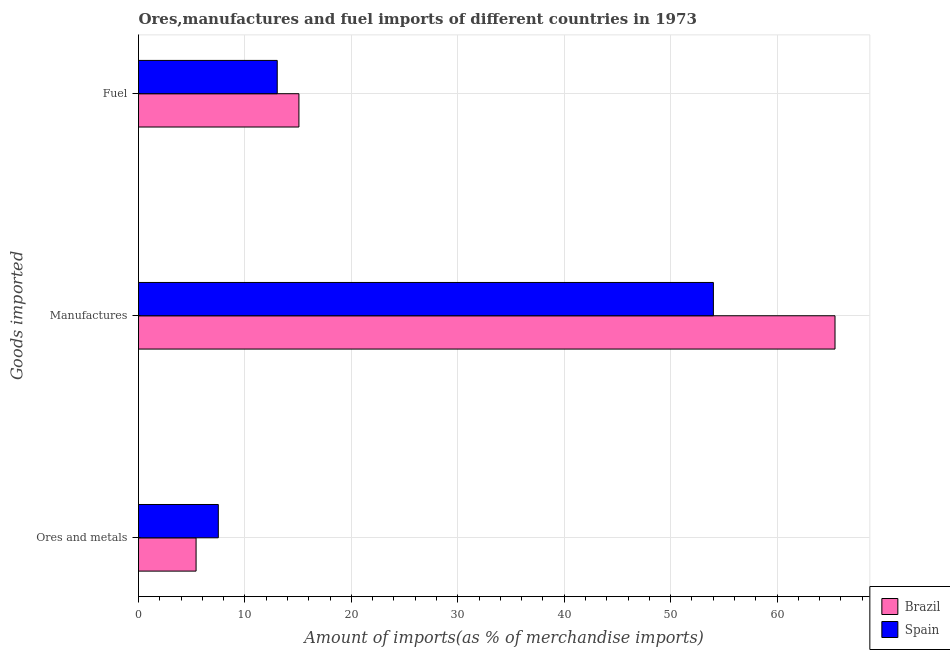Are the number of bars per tick equal to the number of legend labels?
Keep it short and to the point. Yes. Are the number of bars on each tick of the Y-axis equal?
Your answer should be compact. Yes. How many bars are there on the 2nd tick from the top?
Your answer should be compact. 2. What is the label of the 1st group of bars from the top?
Ensure brevity in your answer.  Fuel. What is the percentage of manufactures imports in Spain?
Offer a very short reply. 54.02. Across all countries, what is the maximum percentage of manufactures imports?
Keep it short and to the point. 65.45. Across all countries, what is the minimum percentage of fuel imports?
Your response must be concise. 13.04. In which country was the percentage of fuel imports minimum?
Your response must be concise. Spain. What is the total percentage of fuel imports in the graph?
Your answer should be compact. 28.11. What is the difference between the percentage of manufactures imports in Brazil and that in Spain?
Your answer should be very brief. 11.43. What is the difference between the percentage of fuel imports in Brazil and the percentage of manufactures imports in Spain?
Keep it short and to the point. -38.95. What is the average percentage of manufactures imports per country?
Your answer should be very brief. 59.73. What is the difference between the percentage of manufactures imports and percentage of fuel imports in Spain?
Make the answer very short. 40.98. In how many countries, is the percentage of ores and metals imports greater than 46 %?
Your response must be concise. 0. What is the ratio of the percentage of manufactures imports in Spain to that in Brazil?
Make the answer very short. 0.83. Is the percentage of ores and metals imports in Brazil less than that in Spain?
Your answer should be compact. Yes. Is the difference between the percentage of manufactures imports in Spain and Brazil greater than the difference between the percentage of fuel imports in Spain and Brazil?
Your response must be concise. No. What is the difference between the highest and the second highest percentage of manufactures imports?
Your response must be concise. 11.43. What is the difference between the highest and the lowest percentage of ores and metals imports?
Ensure brevity in your answer.  2.09. In how many countries, is the percentage of fuel imports greater than the average percentage of fuel imports taken over all countries?
Keep it short and to the point. 1. What does the 2nd bar from the bottom in Fuel represents?
Offer a very short reply. Spain. How many bars are there?
Ensure brevity in your answer.  6. How many countries are there in the graph?
Your answer should be very brief. 2. What is the difference between two consecutive major ticks on the X-axis?
Give a very brief answer. 10. Does the graph contain any zero values?
Offer a very short reply. No. Does the graph contain grids?
Provide a succinct answer. Yes. How are the legend labels stacked?
Offer a very short reply. Vertical. What is the title of the graph?
Provide a short and direct response. Ores,manufactures and fuel imports of different countries in 1973. What is the label or title of the X-axis?
Keep it short and to the point. Amount of imports(as % of merchandise imports). What is the label or title of the Y-axis?
Offer a very short reply. Goods imported. What is the Amount of imports(as % of merchandise imports) of Brazil in Ores and metals?
Your answer should be very brief. 5.41. What is the Amount of imports(as % of merchandise imports) in Spain in Ores and metals?
Your answer should be very brief. 7.5. What is the Amount of imports(as % of merchandise imports) of Brazil in Manufactures?
Provide a succinct answer. 65.45. What is the Amount of imports(as % of merchandise imports) in Spain in Manufactures?
Make the answer very short. 54.02. What is the Amount of imports(as % of merchandise imports) in Brazil in Fuel?
Provide a succinct answer. 15.07. What is the Amount of imports(as % of merchandise imports) of Spain in Fuel?
Your response must be concise. 13.04. Across all Goods imported, what is the maximum Amount of imports(as % of merchandise imports) in Brazil?
Your response must be concise. 65.45. Across all Goods imported, what is the maximum Amount of imports(as % of merchandise imports) in Spain?
Provide a succinct answer. 54.02. Across all Goods imported, what is the minimum Amount of imports(as % of merchandise imports) of Brazil?
Provide a succinct answer. 5.41. Across all Goods imported, what is the minimum Amount of imports(as % of merchandise imports) of Spain?
Ensure brevity in your answer.  7.5. What is the total Amount of imports(as % of merchandise imports) of Brazil in the graph?
Make the answer very short. 85.93. What is the total Amount of imports(as % of merchandise imports) of Spain in the graph?
Your response must be concise. 74.55. What is the difference between the Amount of imports(as % of merchandise imports) in Brazil in Ores and metals and that in Manufactures?
Give a very brief answer. -60.04. What is the difference between the Amount of imports(as % of merchandise imports) in Spain in Ores and metals and that in Manufactures?
Your response must be concise. -46.52. What is the difference between the Amount of imports(as % of merchandise imports) in Brazil in Ores and metals and that in Fuel?
Ensure brevity in your answer.  -9.66. What is the difference between the Amount of imports(as % of merchandise imports) of Spain in Ores and metals and that in Fuel?
Make the answer very short. -5.54. What is the difference between the Amount of imports(as % of merchandise imports) in Brazil in Manufactures and that in Fuel?
Your answer should be very brief. 50.37. What is the difference between the Amount of imports(as % of merchandise imports) of Spain in Manufactures and that in Fuel?
Your response must be concise. 40.98. What is the difference between the Amount of imports(as % of merchandise imports) of Brazil in Ores and metals and the Amount of imports(as % of merchandise imports) of Spain in Manufactures?
Keep it short and to the point. -48.61. What is the difference between the Amount of imports(as % of merchandise imports) in Brazil in Ores and metals and the Amount of imports(as % of merchandise imports) in Spain in Fuel?
Give a very brief answer. -7.63. What is the difference between the Amount of imports(as % of merchandise imports) in Brazil in Manufactures and the Amount of imports(as % of merchandise imports) in Spain in Fuel?
Provide a short and direct response. 52.41. What is the average Amount of imports(as % of merchandise imports) in Brazil per Goods imported?
Your answer should be compact. 28.64. What is the average Amount of imports(as % of merchandise imports) of Spain per Goods imported?
Offer a very short reply. 24.85. What is the difference between the Amount of imports(as % of merchandise imports) in Brazil and Amount of imports(as % of merchandise imports) in Spain in Ores and metals?
Offer a very short reply. -2.09. What is the difference between the Amount of imports(as % of merchandise imports) of Brazil and Amount of imports(as % of merchandise imports) of Spain in Manufactures?
Offer a terse response. 11.43. What is the difference between the Amount of imports(as % of merchandise imports) of Brazil and Amount of imports(as % of merchandise imports) of Spain in Fuel?
Give a very brief answer. 2.04. What is the ratio of the Amount of imports(as % of merchandise imports) of Brazil in Ores and metals to that in Manufactures?
Provide a short and direct response. 0.08. What is the ratio of the Amount of imports(as % of merchandise imports) in Spain in Ores and metals to that in Manufactures?
Make the answer very short. 0.14. What is the ratio of the Amount of imports(as % of merchandise imports) of Brazil in Ores and metals to that in Fuel?
Your answer should be compact. 0.36. What is the ratio of the Amount of imports(as % of merchandise imports) in Spain in Ores and metals to that in Fuel?
Ensure brevity in your answer.  0.58. What is the ratio of the Amount of imports(as % of merchandise imports) in Brazil in Manufactures to that in Fuel?
Give a very brief answer. 4.34. What is the ratio of the Amount of imports(as % of merchandise imports) of Spain in Manufactures to that in Fuel?
Your answer should be very brief. 4.14. What is the difference between the highest and the second highest Amount of imports(as % of merchandise imports) of Brazil?
Offer a terse response. 50.37. What is the difference between the highest and the second highest Amount of imports(as % of merchandise imports) of Spain?
Offer a terse response. 40.98. What is the difference between the highest and the lowest Amount of imports(as % of merchandise imports) of Brazil?
Provide a succinct answer. 60.04. What is the difference between the highest and the lowest Amount of imports(as % of merchandise imports) in Spain?
Your answer should be compact. 46.52. 